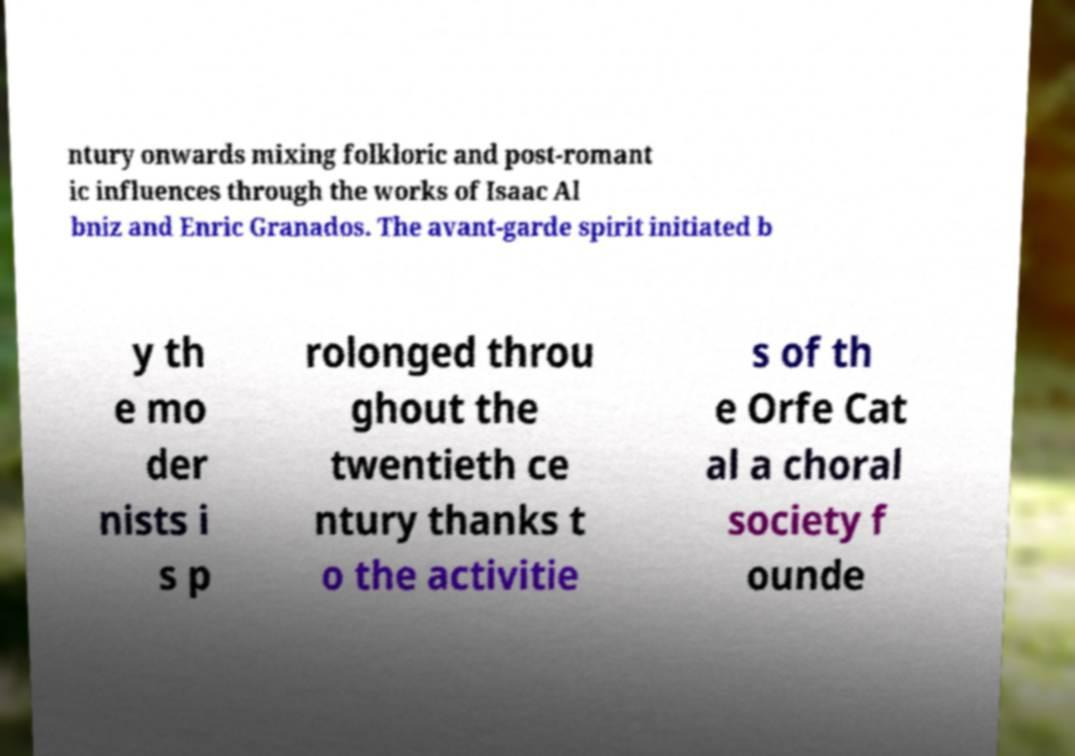What messages or text are displayed in this image? I need them in a readable, typed format. ntury onwards mixing folkloric and post-romant ic influences through the works of Isaac Al bniz and Enric Granados. The avant-garde spirit initiated b y th e mo der nists i s p rolonged throu ghout the twentieth ce ntury thanks t o the activitie s of th e Orfe Cat al a choral society f ounde 